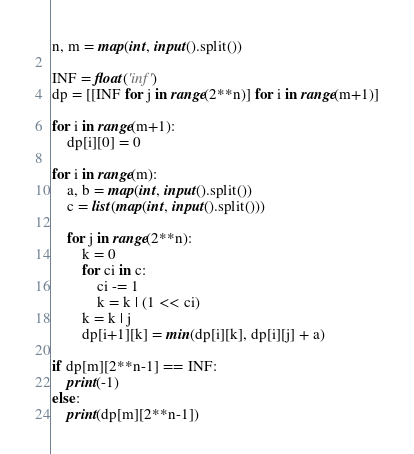<code> <loc_0><loc_0><loc_500><loc_500><_Python_>n, m = map(int, input().split())

INF = float('inf')
dp = [[INF for j in range(2**n)] for i in range(m+1)]

for i in range(m+1):
    dp[i][0] = 0

for i in range(m):
    a, b = map(int, input().split())
    c = list(map(int, input().split()))

    for j in range(2**n):
        k = 0
        for ci in c:
            ci -= 1
            k = k | (1 << ci)
        k = k | j
        dp[i+1][k] = min(dp[i][k], dp[i][j] + a)

if dp[m][2**n-1] == INF:
    print(-1)
else:
    print(dp[m][2**n-1])

</code> 